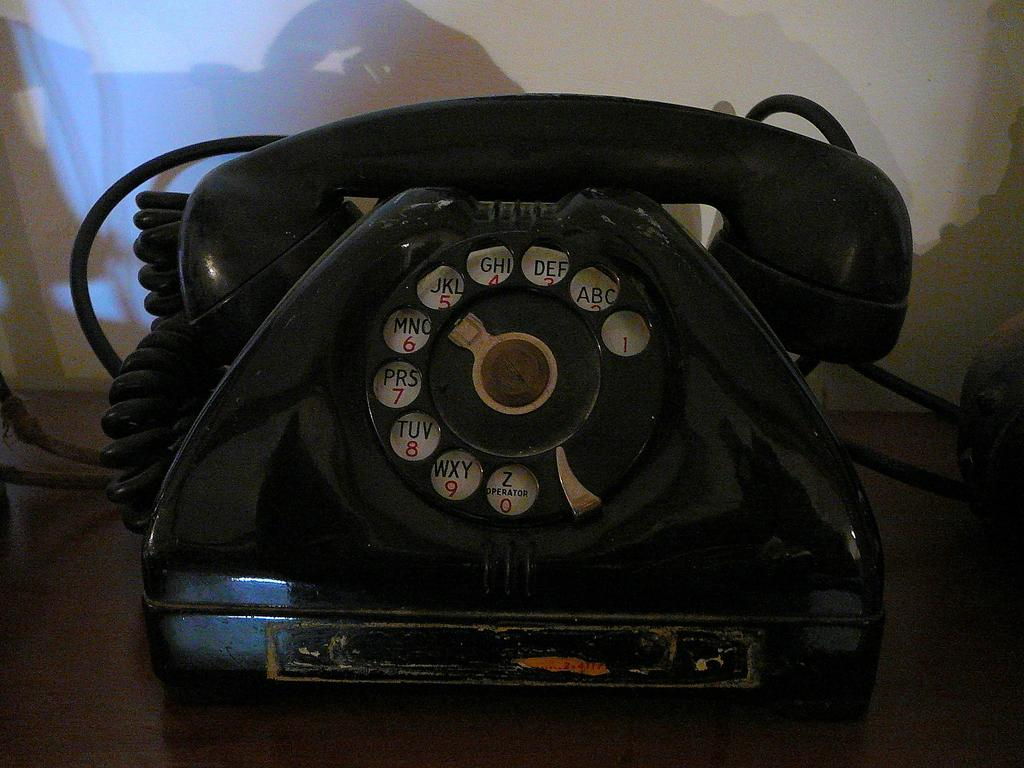What object is the main focus of the image? There is a telephone in the image. Where is the telephone located? The telephone is on a platform. What color is the background of the image? The background of the image is white. What type of battle is depicted in the image? There is no battle depicted in the image; it features a telephone on a platform with a white background. How does the journey of the telephone change throughout the image? The telephone does not change its journey in the image; it remains stationary on the platform. 